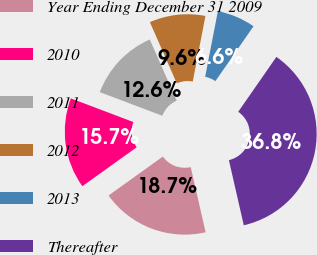<chart> <loc_0><loc_0><loc_500><loc_500><pie_chart><fcel>Year Ending December 31 2009<fcel>2010<fcel>2011<fcel>2012<fcel>2013<fcel>Thereafter<nl><fcel>18.68%<fcel>15.66%<fcel>12.65%<fcel>9.64%<fcel>6.62%<fcel>36.76%<nl></chart> 